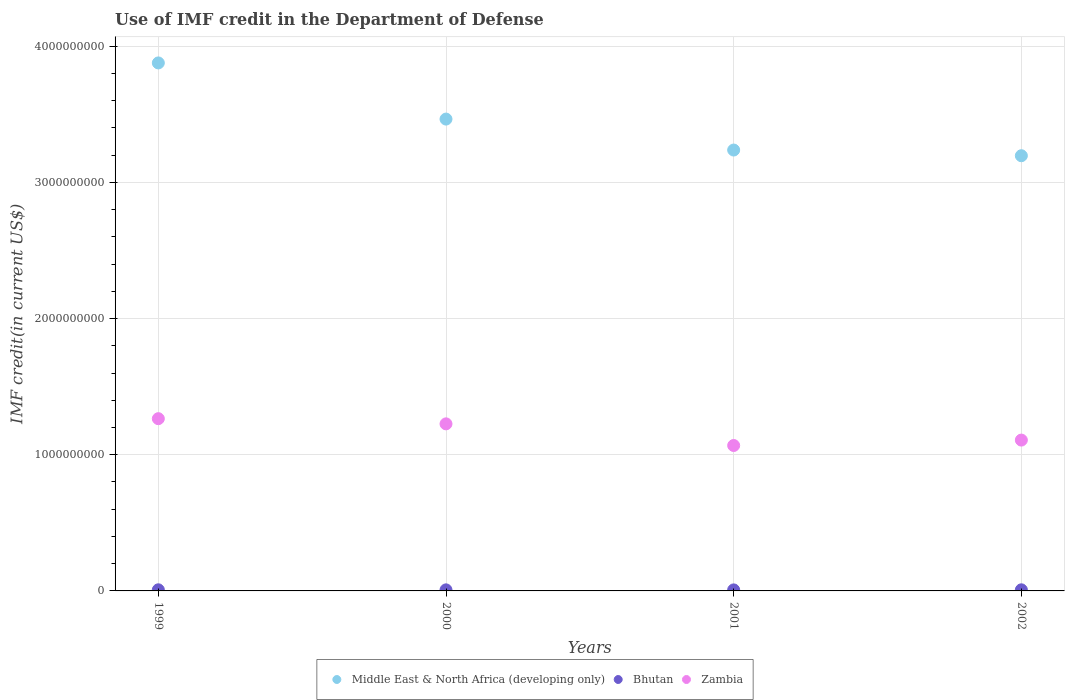How many different coloured dotlines are there?
Make the answer very short. 3. What is the IMF credit in the Department of Defense in Bhutan in 2001?
Your answer should be very brief. 7.53e+06. Across all years, what is the maximum IMF credit in the Department of Defense in Bhutan?
Give a very brief answer. 8.22e+06. Across all years, what is the minimum IMF credit in the Department of Defense in Middle East & North Africa (developing only)?
Offer a terse response. 3.20e+09. What is the total IMF credit in the Department of Defense in Middle East & North Africa (developing only) in the graph?
Your response must be concise. 1.38e+1. What is the difference between the IMF credit in the Department of Defense in Middle East & North Africa (developing only) in 2000 and that in 2002?
Keep it short and to the point. 2.69e+08. What is the difference between the IMF credit in the Department of Defense in Bhutan in 2002 and the IMF credit in the Department of Defense in Zambia in 2000?
Your answer should be very brief. -1.22e+09. What is the average IMF credit in the Department of Defense in Bhutan per year?
Your answer should be compact. 7.92e+06. In the year 1999, what is the difference between the IMF credit in the Department of Defense in Zambia and IMF credit in the Department of Defense in Bhutan?
Your answer should be very brief. 1.26e+09. In how many years, is the IMF credit in the Department of Defense in Middle East & North Africa (developing only) greater than 2800000000 US$?
Keep it short and to the point. 4. What is the ratio of the IMF credit in the Department of Defense in Zambia in 1999 to that in 2002?
Your answer should be very brief. 1.14. Is the IMF credit in the Department of Defense in Zambia in 1999 less than that in 2000?
Your answer should be very brief. No. Is the difference between the IMF credit in the Department of Defense in Zambia in 1999 and 2002 greater than the difference between the IMF credit in the Department of Defense in Bhutan in 1999 and 2002?
Ensure brevity in your answer.  Yes. What is the difference between the highest and the second highest IMF credit in the Department of Defense in Middle East & North Africa (developing only)?
Provide a short and direct response. 4.13e+08. What is the difference between the highest and the lowest IMF credit in the Department of Defense in Bhutan?
Offer a very short reply. 6.94e+05. Is it the case that in every year, the sum of the IMF credit in the Department of Defense in Zambia and IMF credit in the Department of Defense in Middle East & North Africa (developing only)  is greater than the IMF credit in the Department of Defense in Bhutan?
Give a very brief answer. Yes. Does the IMF credit in the Department of Defense in Middle East & North Africa (developing only) monotonically increase over the years?
Make the answer very short. No. Is the IMF credit in the Department of Defense in Zambia strictly greater than the IMF credit in the Department of Defense in Middle East & North Africa (developing only) over the years?
Keep it short and to the point. No. Is the IMF credit in the Department of Defense in Zambia strictly less than the IMF credit in the Department of Defense in Bhutan over the years?
Ensure brevity in your answer.  No. How many years are there in the graph?
Provide a succinct answer. 4. Are the values on the major ticks of Y-axis written in scientific E-notation?
Keep it short and to the point. No. Where does the legend appear in the graph?
Your answer should be compact. Bottom center. How are the legend labels stacked?
Your answer should be compact. Horizontal. What is the title of the graph?
Give a very brief answer. Use of IMF credit in the Department of Defense. What is the label or title of the Y-axis?
Keep it short and to the point. IMF credit(in current US$). What is the IMF credit(in current US$) of Middle East & North Africa (developing only) in 1999?
Ensure brevity in your answer.  3.88e+09. What is the IMF credit(in current US$) in Bhutan in 1999?
Offer a terse response. 8.22e+06. What is the IMF credit(in current US$) of Zambia in 1999?
Your answer should be very brief. 1.27e+09. What is the IMF credit(in current US$) in Middle East & North Africa (developing only) in 2000?
Offer a terse response. 3.47e+09. What is the IMF credit(in current US$) of Bhutan in 2000?
Offer a terse response. 7.80e+06. What is the IMF credit(in current US$) in Zambia in 2000?
Your response must be concise. 1.23e+09. What is the IMF credit(in current US$) in Middle East & North Africa (developing only) in 2001?
Provide a short and direct response. 3.24e+09. What is the IMF credit(in current US$) of Bhutan in 2001?
Provide a short and direct response. 7.53e+06. What is the IMF credit(in current US$) in Zambia in 2001?
Make the answer very short. 1.07e+09. What is the IMF credit(in current US$) in Middle East & North Africa (developing only) in 2002?
Your response must be concise. 3.20e+09. What is the IMF credit(in current US$) in Bhutan in 2002?
Offer a terse response. 8.14e+06. What is the IMF credit(in current US$) of Zambia in 2002?
Make the answer very short. 1.11e+09. Across all years, what is the maximum IMF credit(in current US$) of Middle East & North Africa (developing only)?
Give a very brief answer. 3.88e+09. Across all years, what is the maximum IMF credit(in current US$) of Bhutan?
Your answer should be very brief. 8.22e+06. Across all years, what is the maximum IMF credit(in current US$) of Zambia?
Your answer should be very brief. 1.27e+09. Across all years, what is the minimum IMF credit(in current US$) in Middle East & North Africa (developing only)?
Ensure brevity in your answer.  3.20e+09. Across all years, what is the minimum IMF credit(in current US$) of Bhutan?
Provide a succinct answer. 7.53e+06. Across all years, what is the minimum IMF credit(in current US$) in Zambia?
Offer a terse response. 1.07e+09. What is the total IMF credit(in current US$) in Middle East & North Africa (developing only) in the graph?
Ensure brevity in your answer.  1.38e+1. What is the total IMF credit(in current US$) of Bhutan in the graph?
Your answer should be compact. 3.17e+07. What is the total IMF credit(in current US$) in Zambia in the graph?
Provide a short and direct response. 4.67e+09. What is the difference between the IMF credit(in current US$) in Middle East & North Africa (developing only) in 1999 and that in 2000?
Your response must be concise. 4.13e+08. What is the difference between the IMF credit(in current US$) in Bhutan in 1999 and that in 2000?
Make the answer very short. 4.17e+05. What is the difference between the IMF credit(in current US$) in Zambia in 1999 and that in 2000?
Offer a terse response. 3.81e+07. What is the difference between the IMF credit(in current US$) of Middle East & North Africa (developing only) in 1999 and that in 2001?
Give a very brief answer. 6.40e+08. What is the difference between the IMF credit(in current US$) of Bhutan in 1999 and that in 2001?
Ensure brevity in your answer.  6.94e+05. What is the difference between the IMF credit(in current US$) in Zambia in 1999 and that in 2001?
Give a very brief answer. 1.97e+08. What is the difference between the IMF credit(in current US$) in Middle East & North Africa (developing only) in 1999 and that in 2002?
Give a very brief answer. 6.82e+08. What is the difference between the IMF credit(in current US$) in Bhutan in 1999 and that in 2002?
Make the answer very short. 7.80e+04. What is the difference between the IMF credit(in current US$) in Zambia in 1999 and that in 2002?
Offer a terse response. 1.57e+08. What is the difference between the IMF credit(in current US$) in Middle East & North Africa (developing only) in 2000 and that in 2001?
Your answer should be very brief. 2.27e+08. What is the difference between the IMF credit(in current US$) of Bhutan in 2000 and that in 2001?
Offer a terse response. 2.77e+05. What is the difference between the IMF credit(in current US$) of Zambia in 2000 and that in 2001?
Keep it short and to the point. 1.59e+08. What is the difference between the IMF credit(in current US$) in Middle East & North Africa (developing only) in 2000 and that in 2002?
Make the answer very short. 2.69e+08. What is the difference between the IMF credit(in current US$) of Bhutan in 2000 and that in 2002?
Your answer should be very brief. -3.39e+05. What is the difference between the IMF credit(in current US$) in Zambia in 2000 and that in 2002?
Your response must be concise. 1.19e+08. What is the difference between the IMF credit(in current US$) in Middle East & North Africa (developing only) in 2001 and that in 2002?
Make the answer very short. 4.18e+07. What is the difference between the IMF credit(in current US$) of Bhutan in 2001 and that in 2002?
Offer a very short reply. -6.16e+05. What is the difference between the IMF credit(in current US$) in Zambia in 2001 and that in 2002?
Your response must be concise. -3.98e+07. What is the difference between the IMF credit(in current US$) of Middle East & North Africa (developing only) in 1999 and the IMF credit(in current US$) of Bhutan in 2000?
Your answer should be very brief. 3.87e+09. What is the difference between the IMF credit(in current US$) of Middle East & North Africa (developing only) in 1999 and the IMF credit(in current US$) of Zambia in 2000?
Offer a terse response. 2.65e+09. What is the difference between the IMF credit(in current US$) in Bhutan in 1999 and the IMF credit(in current US$) in Zambia in 2000?
Your answer should be very brief. -1.22e+09. What is the difference between the IMF credit(in current US$) of Middle East & North Africa (developing only) in 1999 and the IMF credit(in current US$) of Bhutan in 2001?
Make the answer very short. 3.87e+09. What is the difference between the IMF credit(in current US$) in Middle East & North Africa (developing only) in 1999 and the IMF credit(in current US$) in Zambia in 2001?
Give a very brief answer. 2.81e+09. What is the difference between the IMF credit(in current US$) of Bhutan in 1999 and the IMF credit(in current US$) of Zambia in 2001?
Give a very brief answer. -1.06e+09. What is the difference between the IMF credit(in current US$) of Middle East & North Africa (developing only) in 1999 and the IMF credit(in current US$) of Bhutan in 2002?
Keep it short and to the point. 3.87e+09. What is the difference between the IMF credit(in current US$) of Middle East & North Africa (developing only) in 1999 and the IMF credit(in current US$) of Zambia in 2002?
Make the answer very short. 2.77e+09. What is the difference between the IMF credit(in current US$) of Bhutan in 1999 and the IMF credit(in current US$) of Zambia in 2002?
Offer a very short reply. -1.10e+09. What is the difference between the IMF credit(in current US$) of Middle East & North Africa (developing only) in 2000 and the IMF credit(in current US$) of Bhutan in 2001?
Give a very brief answer. 3.46e+09. What is the difference between the IMF credit(in current US$) in Middle East & North Africa (developing only) in 2000 and the IMF credit(in current US$) in Zambia in 2001?
Provide a short and direct response. 2.40e+09. What is the difference between the IMF credit(in current US$) of Bhutan in 2000 and the IMF credit(in current US$) of Zambia in 2001?
Your response must be concise. -1.06e+09. What is the difference between the IMF credit(in current US$) of Middle East & North Africa (developing only) in 2000 and the IMF credit(in current US$) of Bhutan in 2002?
Your answer should be compact. 3.46e+09. What is the difference between the IMF credit(in current US$) in Middle East & North Africa (developing only) in 2000 and the IMF credit(in current US$) in Zambia in 2002?
Your answer should be compact. 2.36e+09. What is the difference between the IMF credit(in current US$) in Bhutan in 2000 and the IMF credit(in current US$) in Zambia in 2002?
Ensure brevity in your answer.  -1.10e+09. What is the difference between the IMF credit(in current US$) of Middle East & North Africa (developing only) in 2001 and the IMF credit(in current US$) of Bhutan in 2002?
Give a very brief answer. 3.23e+09. What is the difference between the IMF credit(in current US$) in Middle East & North Africa (developing only) in 2001 and the IMF credit(in current US$) in Zambia in 2002?
Provide a short and direct response. 2.13e+09. What is the difference between the IMF credit(in current US$) of Bhutan in 2001 and the IMF credit(in current US$) of Zambia in 2002?
Your answer should be very brief. -1.10e+09. What is the average IMF credit(in current US$) in Middle East & North Africa (developing only) per year?
Give a very brief answer. 3.44e+09. What is the average IMF credit(in current US$) of Bhutan per year?
Provide a short and direct response. 7.92e+06. What is the average IMF credit(in current US$) of Zambia per year?
Give a very brief answer. 1.17e+09. In the year 1999, what is the difference between the IMF credit(in current US$) of Middle East & North Africa (developing only) and IMF credit(in current US$) of Bhutan?
Offer a terse response. 3.87e+09. In the year 1999, what is the difference between the IMF credit(in current US$) in Middle East & North Africa (developing only) and IMF credit(in current US$) in Zambia?
Ensure brevity in your answer.  2.61e+09. In the year 1999, what is the difference between the IMF credit(in current US$) in Bhutan and IMF credit(in current US$) in Zambia?
Give a very brief answer. -1.26e+09. In the year 2000, what is the difference between the IMF credit(in current US$) of Middle East & North Africa (developing only) and IMF credit(in current US$) of Bhutan?
Make the answer very short. 3.46e+09. In the year 2000, what is the difference between the IMF credit(in current US$) in Middle East & North Africa (developing only) and IMF credit(in current US$) in Zambia?
Ensure brevity in your answer.  2.24e+09. In the year 2000, what is the difference between the IMF credit(in current US$) in Bhutan and IMF credit(in current US$) in Zambia?
Make the answer very short. -1.22e+09. In the year 2001, what is the difference between the IMF credit(in current US$) of Middle East & North Africa (developing only) and IMF credit(in current US$) of Bhutan?
Your answer should be very brief. 3.23e+09. In the year 2001, what is the difference between the IMF credit(in current US$) of Middle East & North Africa (developing only) and IMF credit(in current US$) of Zambia?
Ensure brevity in your answer.  2.17e+09. In the year 2001, what is the difference between the IMF credit(in current US$) in Bhutan and IMF credit(in current US$) in Zambia?
Make the answer very short. -1.06e+09. In the year 2002, what is the difference between the IMF credit(in current US$) of Middle East & North Africa (developing only) and IMF credit(in current US$) of Bhutan?
Provide a short and direct response. 3.19e+09. In the year 2002, what is the difference between the IMF credit(in current US$) in Middle East & North Africa (developing only) and IMF credit(in current US$) in Zambia?
Your response must be concise. 2.09e+09. In the year 2002, what is the difference between the IMF credit(in current US$) in Bhutan and IMF credit(in current US$) in Zambia?
Provide a short and direct response. -1.10e+09. What is the ratio of the IMF credit(in current US$) in Middle East & North Africa (developing only) in 1999 to that in 2000?
Offer a terse response. 1.12. What is the ratio of the IMF credit(in current US$) in Bhutan in 1999 to that in 2000?
Your answer should be compact. 1.05. What is the ratio of the IMF credit(in current US$) in Zambia in 1999 to that in 2000?
Your answer should be very brief. 1.03. What is the ratio of the IMF credit(in current US$) in Middle East & North Africa (developing only) in 1999 to that in 2001?
Give a very brief answer. 1.2. What is the ratio of the IMF credit(in current US$) of Bhutan in 1999 to that in 2001?
Give a very brief answer. 1.09. What is the ratio of the IMF credit(in current US$) of Zambia in 1999 to that in 2001?
Offer a very short reply. 1.18. What is the ratio of the IMF credit(in current US$) of Middle East & North Africa (developing only) in 1999 to that in 2002?
Make the answer very short. 1.21. What is the ratio of the IMF credit(in current US$) of Bhutan in 1999 to that in 2002?
Offer a very short reply. 1.01. What is the ratio of the IMF credit(in current US$) in Zambia in 1999 to that in 2002?
Provide a succinct answer. 1.14. What is the ratio of the IMF credit(in current US$) in Middle East & North Africa (developing only) in 2000 to that in 2001?
Offer a terse response. 1.07. What is the ratio of the IMF credit(in current US$) of Bhutan in 2000 to that in 2001?
Keep it short and to the point. 1.04. What is the ratio of the IMF credit(in current US$) in Zambia in 2000 to that in 2001?
Offer a terse response. 1.15. What is the ratio of the IMF credit(in current US$) in Middle East & North Africa (developing only) in 2000 to that in 2002?
Provide a short and direct response. 1.08. What is the ratio of the IMF credit(in current US$) of Bhutan in 2000 to that in 2002?
Ensure brevity in your answer.  0.96. What is the ratio of the IMF credit(in current US$) in Zambia in 2000 to that in 2002?
Provide a succinct answer. 1.11. What is the ratio of the IMF credit(in current US$) in Middle East & North Africa (developing only) in 2001 to that in 2002?
Your answer should be very brief. 1.01. What is the ratio of the IMF credit(in current US$) of Bhutan in 2001 to that in 2002?
Provide a succinct answer. 0.92. What is the ratio of the IMF credit(in current US$) in Zambia in 2001 to that in 2002?
Keep it short and to the point. 0.96. What is the difference between the highest and the second highest IMF credit(in current US$) of Middle East & North Africa (developing only)?
Your answer should be very brief. 4.13e+08. What is the difference between the highest and the second highest IMF credit(in current US$) of Bhutan?
Your answer should be compact. 7.80e+04. What is the difference between the highest and the second highest IMF credit(in current US$) in Zambia?
Provide a succinct answer. 3.81e+07. What is the difference between the highest and the lowest IMF credit(in current US$) in Middle East & North Africa (developing only)?
Provide a short and direct response. 6.82e+08. What is the difference between the highest and the lowest IMF credit(in current US$) in Bhutan?
Provide a succinct answer. 6.94e+05. What is the difference between the highest and the lowest IMF credit(in current US$) of Zambia?
Offer a terse response. 1.97e+08. 